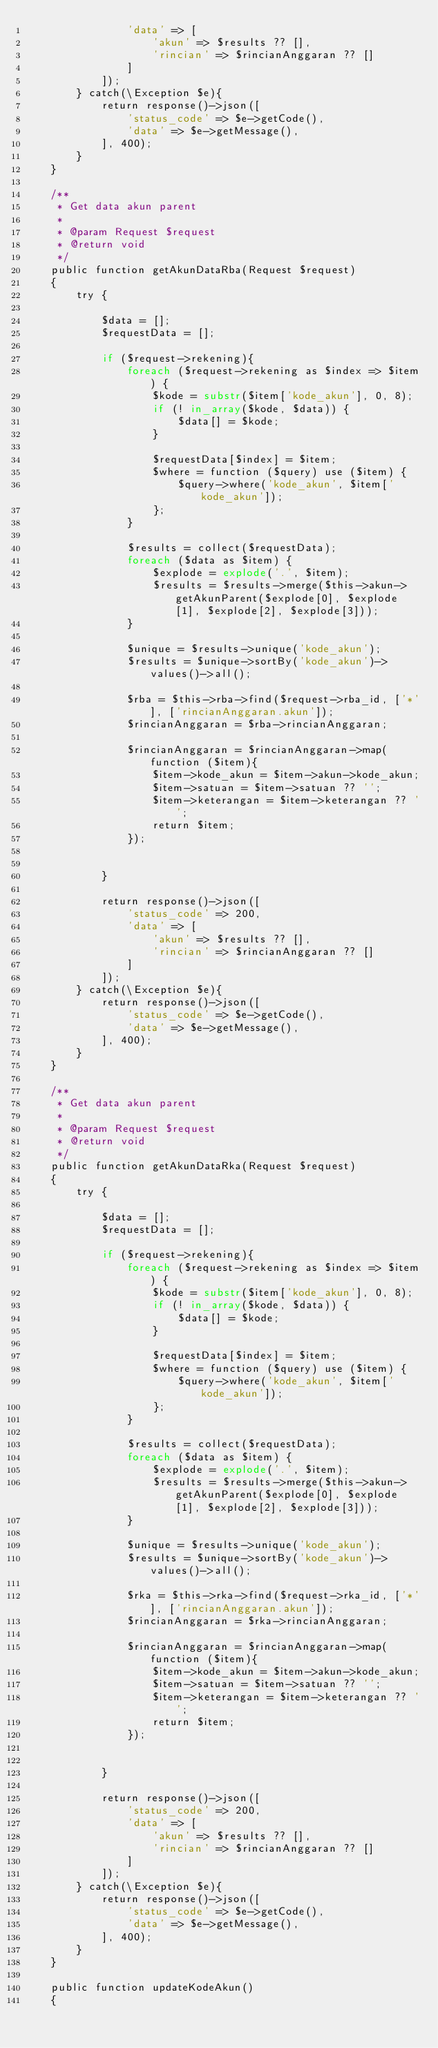<code> <loc_0><loc_0><loc_500><loc_500><_PHP_>                'data' => [
                    'akun' => $results ?? [],
                    'rincian' => $rincianAnggaran ?? []
                ]
            ]);
        } catch(\Exception $e){
            return response()->json([
                'status_code' => $e->getCode(),
                'data' => $e->getMessage(),
            ], 400);
        }
    }

    /**
     * Get data akun parent 
     *
     * @param Request $request
     * @return void
     */
    public function getAkunDataRba(Request $request)
    {
        try {

            $data = [];
            $requestData = [];
            
            if ($request->rekening){
                foreach ($request->rekening as $index => $item) {
                    $kode = substr($item['kode_akun'], 0, 8);
                    if (! in_array($kode, $data)) {
                        $data[] = $kode;
                    }
    
                    $requestData[$index] = $item;
                    $where = function ($query) use ($item) {
                        $query->where('kode_akun', $item['kode_akun']);
                    };
                }
    
                $results = collect($requestData);
                foreach ($data as $item) {
                    $explode = explode('.', $item);
                    $results = $results->merge($this->akun->getAkunParent($explode[0], $explode[1], $explode[2], $explode[3]));
                }
    
                $unique = $results->unique('kode_akun');
                $results = $unique->sortBy('kode_akun')->values()->all();
    
                $rba = $this->rba->find($request->rba_id, ['*'], ['rincianAnggaran.akun']);
                $rincianAnggaran = $rba->rincianAnggaran;
                
                $rincianAnggaran = $rincianAnggaran->map(function ($item){
                    $item->kode_akun = $item->akun->kode_akun;
                    $item->satuan = $item->satuan ?? '';
                    $item->keterangan = $item->keterangan ?? '';
                    return $item;
                });
                
                
            }

            return response()->json([
                'status_code' => 200,
                'data' => [
                    'akun' => $results ?? [],
                    'rincian' => $rincianAnggaran ?? []
                ]
            ]);
        } catch(\Exception $e){
            return response()->json([
                'status_code' => $e->getCode(),
                'data' => $e->getMessage(),
            ], 400);
        }
    }

    /**
     * Get data akun parent 
     *
     * @param Request $request
     * @return void
     */
    public function getAkunDataRka(Request $request)
    {
        try {

            $data = [];
            $requestData = [];

            if ($request->rekening){
                foreach ($request->rekening as $index => $item) {
                    $kode = substr($item['kode_akun'], 0, 8);
                    if (! in_array($kode, $data)) {
                        $data[] = $kode;
                    }
    
                    $requestData[$index] = $item;
                    $where = function ($query) use ($item) {
                        $query->where('kode_akun', $item['kode_akun']);
                    };
                }
    
                $results = collect($requestData);
                foreach ($data as $item) {
                    $explode = explode('.', $item);
                    $results = $results->merge($this->akun->getAkunParent($explode[0], $explode[1], $explode[2], $explode[3]));
                }
    
                $unique = $results->unique('kode_akun');
                $results = $unique->sortBy('kode_akun')->values()->all();
    
                $rka = $this->rka->find($request->rka_id, ['*'], ['rincianAnggaran.akun']);
                $rincianAnggaran = $rka->rincianAnggaran;
                
                $rincianAnggaran = $rincianAnggaran->map(function ($item){
                    $item->kode_akun = $item->akun->kode_akun;
                    $item->satuan = $item->satuan ?? '';
                    $item->keterangan = $item->keterangan ?? '';
                    return $item;
                });
                
                
            }

            return response()->json([
                'status_code' => 200,
                'data' => [
                    'akun' => $results ?? [],
                    'rincian' => $rincianAnggaran ?? []
                ]
            ]);
        } catch(\Exception $e){
            return response()->json([
                'status_code' => $e->getCode(),
                'data' => $e->getMessage(),
            ], 400);
        }
    }

    public function updateKodeAkun()
    {</code> 